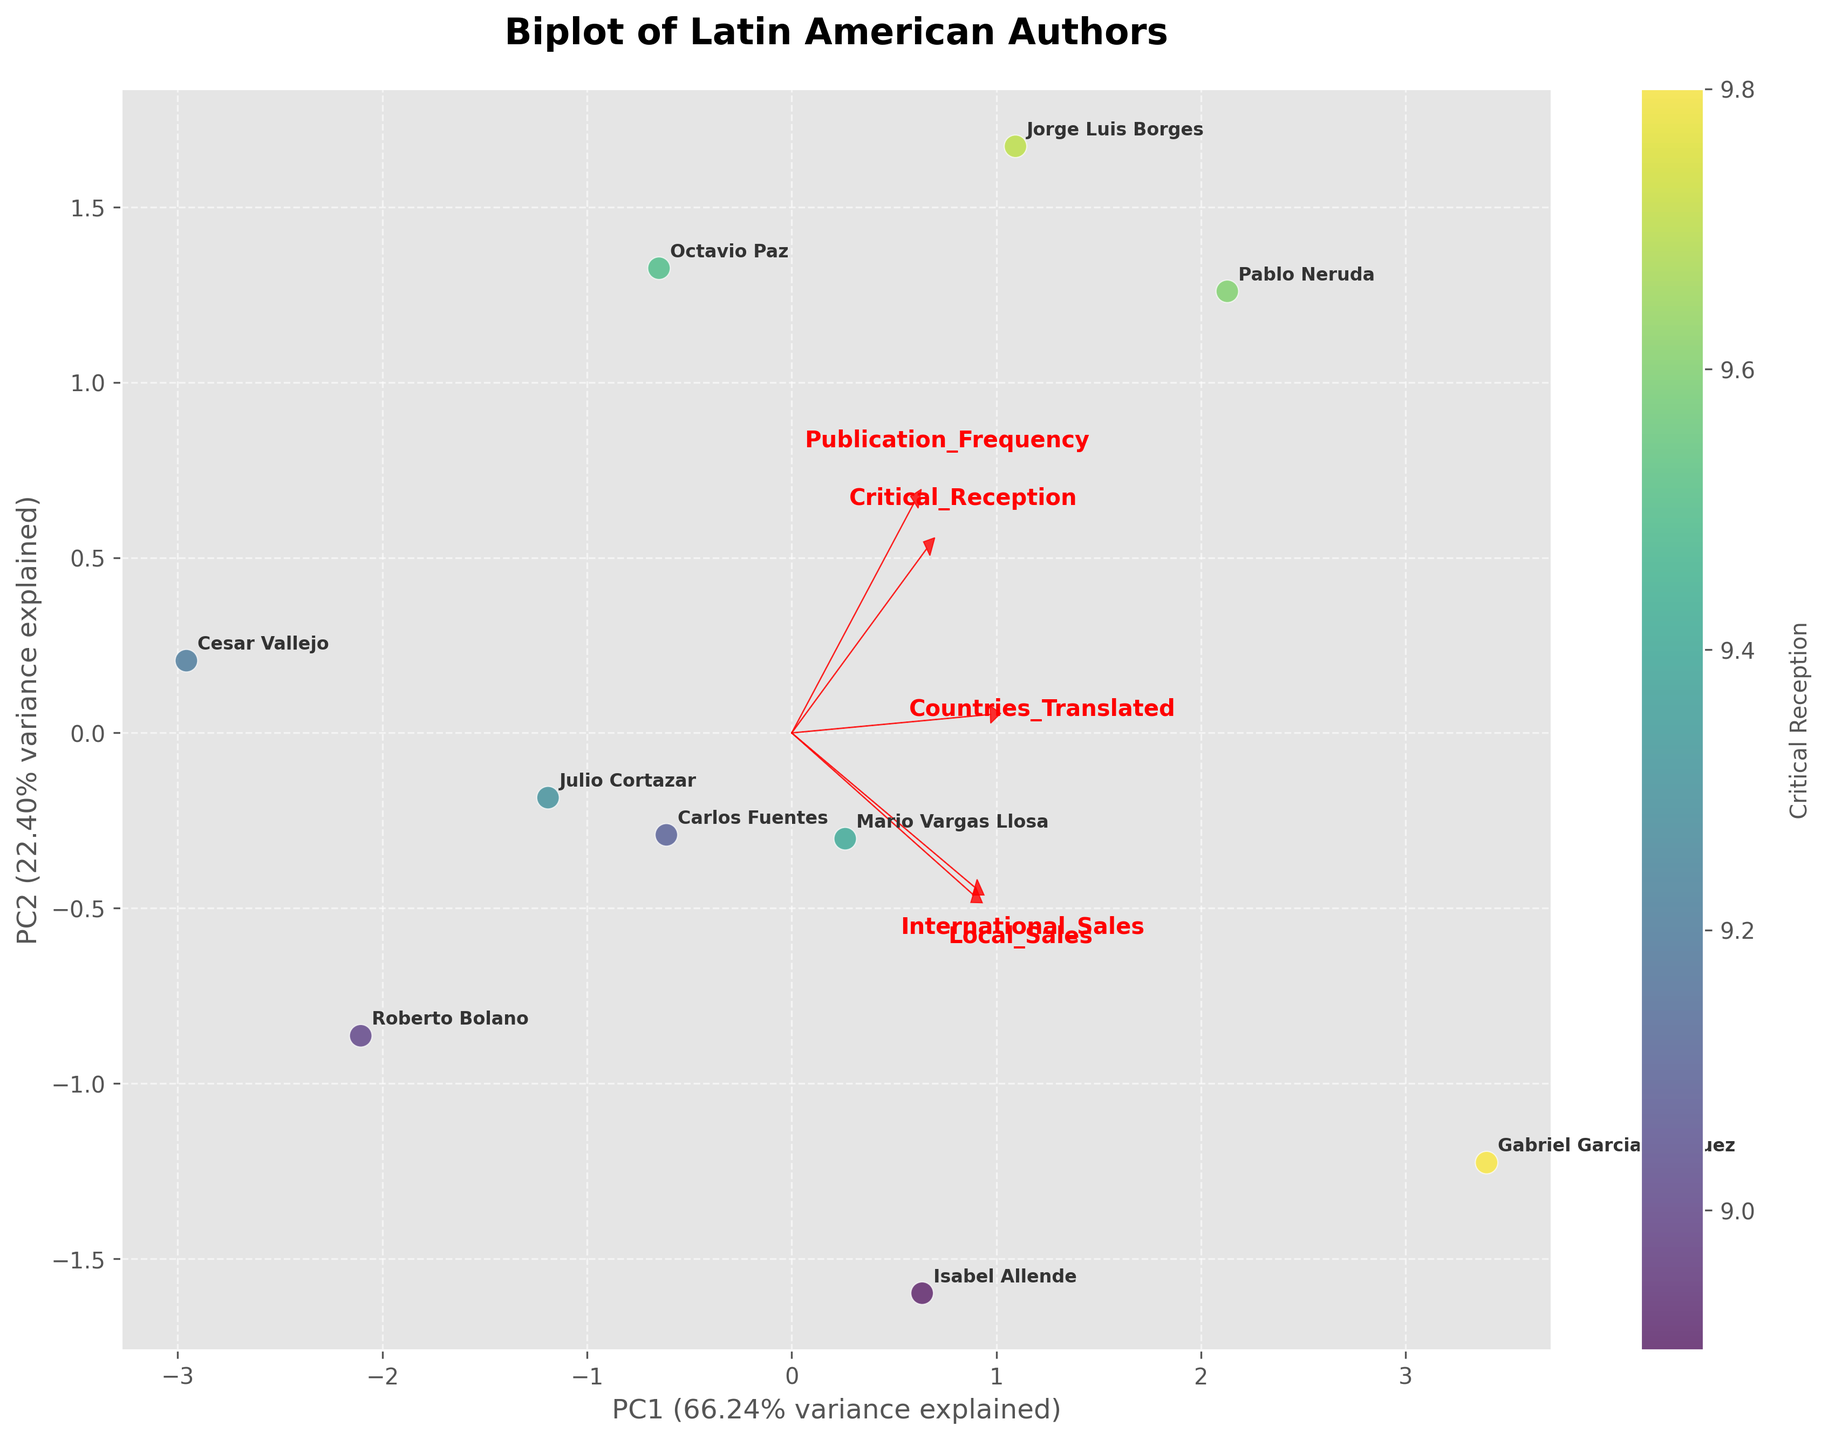Which author has the highest critical reception? By looking at the color intensity on the scatter plot, Gabriel Garcia Marquez stands out with the most vibrant color, indicating the highest critical reception.
Answer: Gabriel Garcia Marquez Which author is located closest to the origin (0,0) in the biplot? The author closest to the origin has the smallest distance from (0,0). Roberto Bolano appears nearest to the origin.
Answer: Roberto Bolano What are the axes labeled in the biplot? The x-axis represents PC1 and the y-axis represents PC2. These labels indicate the first and second principal components derived from PCA.
Answer: PC1 and PC2 How many features have positive loadings on both principal components? Features with positive loadings on both PC1 and PC2 are represented by arrows pointing into the first quadrant. Two features, 'International_Sales' and 'Countries_Translated,' have positive loadings on both components.
Answer: Two Which feature has the highest loading on PC1? To determine this, we should look for the arrow stretching furthest along the PC1 axis. 'International_Sales' has the highest loading on PC1 as its arrow extends furthest in the positive direction along the x-axis.
Answer: International_Sales Is there an author whose critical reception is uneven with their sales numbers? By juxtaposing the critical reception ratings (color intensity) with the scatter plot positions, Mario Vargas Llosa has a high critical reception but lower local sales compared to some authors with similar international sales.
Answer: Mario Vargas Llosa Which author has the maximum countries translated but is still in the bottom half of the Critical Reception scale? 'Countries_Translated' is indicated by the length of the red arrow, and critical reception by color intensity below mid-range. Isabel Allende is positioned lower in critical reception but high in countries translated.
Answer: Isabel Allende What trend can you observe between publication frequency and critical reception? Examining the relative positions and color intensities, authors with higher publication frequencies like Pablo Neruda also tend to have high critical reception, indicating a positive correlation.
Answer: Positive correlation Which feature seems to be least correlated with the first principal component, PC1? The feature with the arrow closest to zero or not extending much in the length along the x-axis indicates minimal correlation with PC1. 'Local_Sales' appears to have the least correlation with PC1.
Answer: Local_Sales Identify an author who excels in international markets relative to their local markets. Authors high on the International_Sales dimension but relatively lower on the Local_Sales scale show this trend. Isabel Allende has significantly higher sales internationally than locally.
Answer: Isabel Allende 